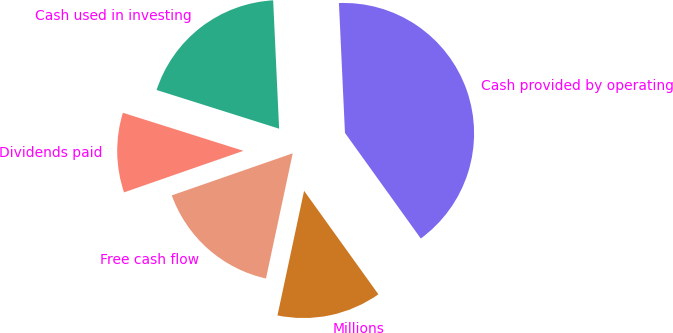Convert chart to OTSL. <chart><loc_0><loc_0><loc_500><loc_500><pie_chart><fcel>Millions<fcel>Cash provided by operating<fcel>Cash used in investing<fcel>Dividends paid<fcel>Free cash flow<nl><fcel>13.26%<fcel>40.83%<fcel>19.39%<fcel>10.2%<fcel>16.32%<nl></chart> 